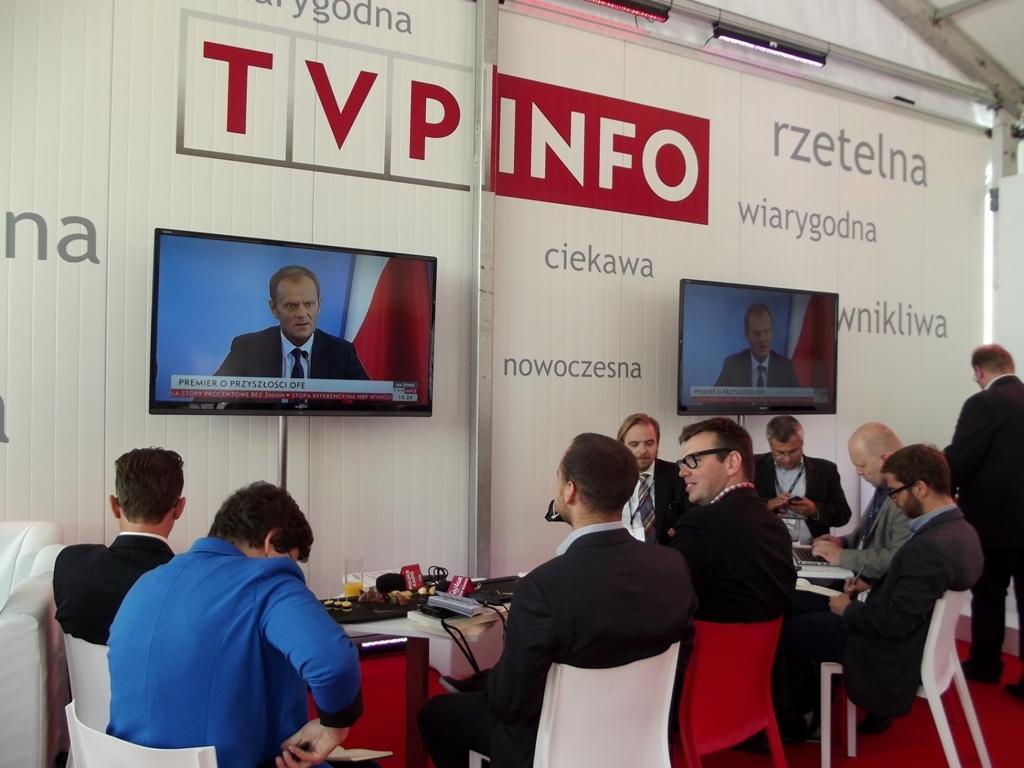In one or two sentences, can you explain what this image depicts? In this image, we can see two televisions with screens and rods. At the bottom, we can see a group of people. Few people are sitting on the chairs. Here there are few tables. So many things and objects are placed on it. Background there is a wall. Here we can see some text. On the right side, a person is standing on the floor. 